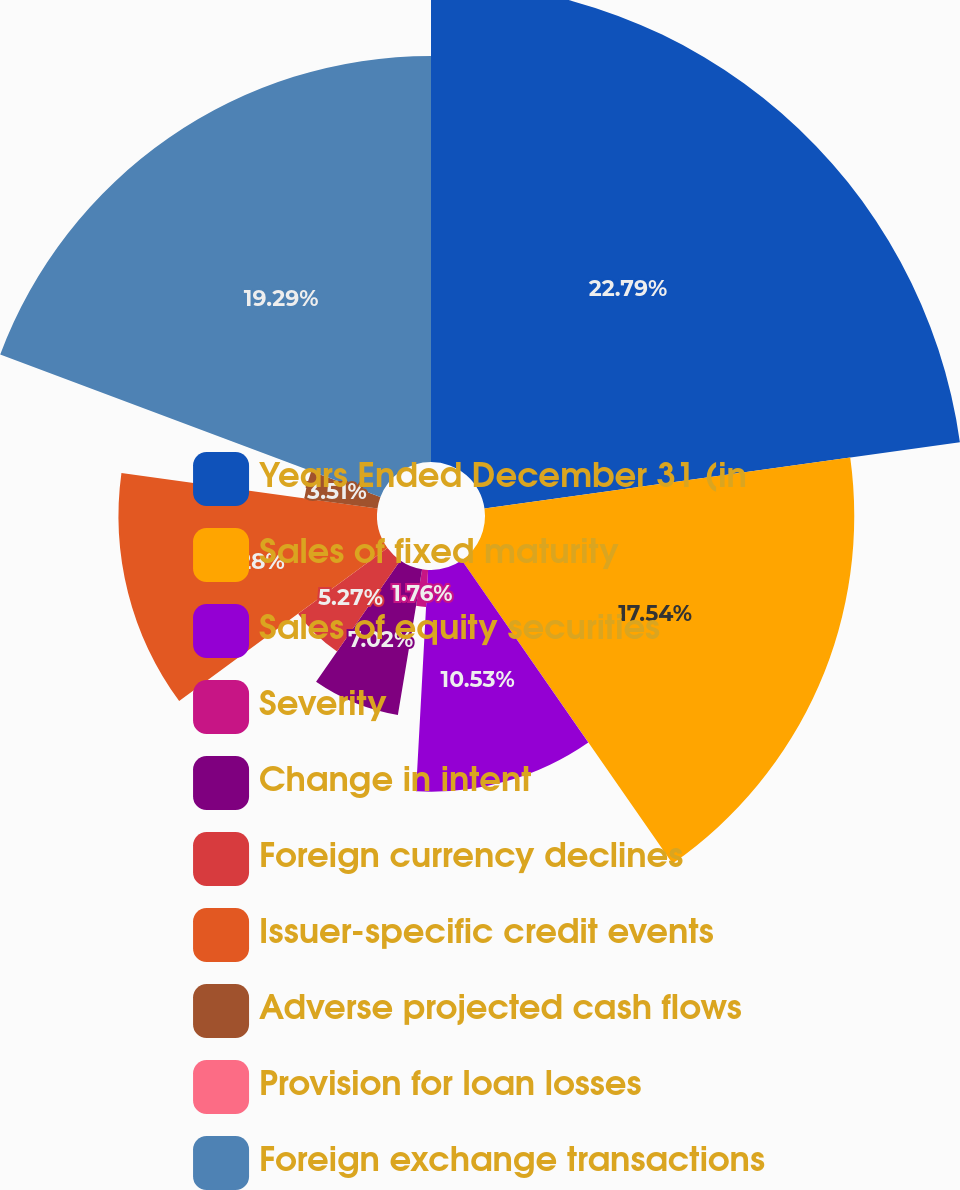Convert chart. <chart><loc_0><loc_0><loc_500><loc_500><pie_chart><fcel>Years Ended December 31 (in<fcel>Sales of fixed maturity<fcel>Sales of equity securities<fcel>Severity<fcel>Change in intent<fcel>Foreign currency declines<fcel>Issuer-specific credit events<fcel>Adverse projected cash flows<fcel>Provision for loan losses<fcel>Foreign exchange transactions<nl><fcel>22.8%<fcel>17.54%<fcel>10.53%<fcel>1.76%<fcel>7.02%<fcel>5.27%<fcel>12.28%<fcel>3.51%<fcel>0.01%<fcel>19.29%<nl></chart> 